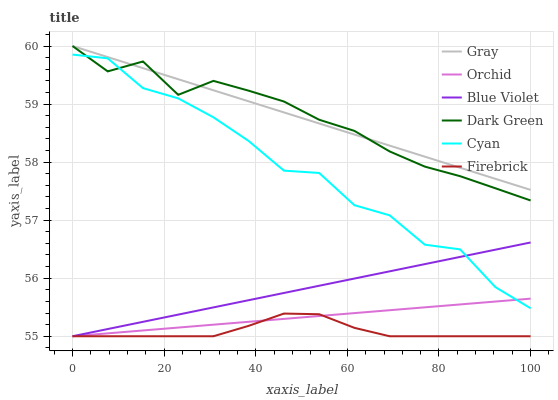Does Firebrick have the minimum area under the curve?
Answer yes or no. Yes. Does Gray have the maximum area under the curve?
Answer yes or no. Yes. Does Cyan have the minimum area under the curve?
Answer yes or no. No. Does Cyan have the maximum area under the curve?
Answer yes or no. No. Is Orchid the smoothest?
Answer yes or no. Yes. Is Cyan the roughest?
Answer yes or no. Yes. Is Firebrick the smoothest?
Answer yes or no. No. Is Firebrick the roughest?
Answer yes or no. No. Does Cyan have the lowest value?
Answer yes or no. No. Does Dark Green have the highest value?
Answer yes or no. Yes. Does Cyan have the highest value?
Answer yes or no. No. Is Cyan less than Gray?
Answer yes or no. Yes. Is Cyan greater than Firebrick?
Answer yes or no. Yes. Does Cyan intersect Dark Green?
Answer yes or no. Yes. Is Cyan less than Dark Green?
Answer yes or no. No. Is Cyan greater than Dark Green?
Answer yes or no. No. Does Cyan intersect Gray?
Answer yes or no. No. 